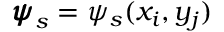Convert formula to latex. <formula><loc_0><loc_0><loc_500><loc_500>{ \pm b { \psi } } _ { s } = \psi _ { s } ( x _ { i } , y _ { j } )</formula> 